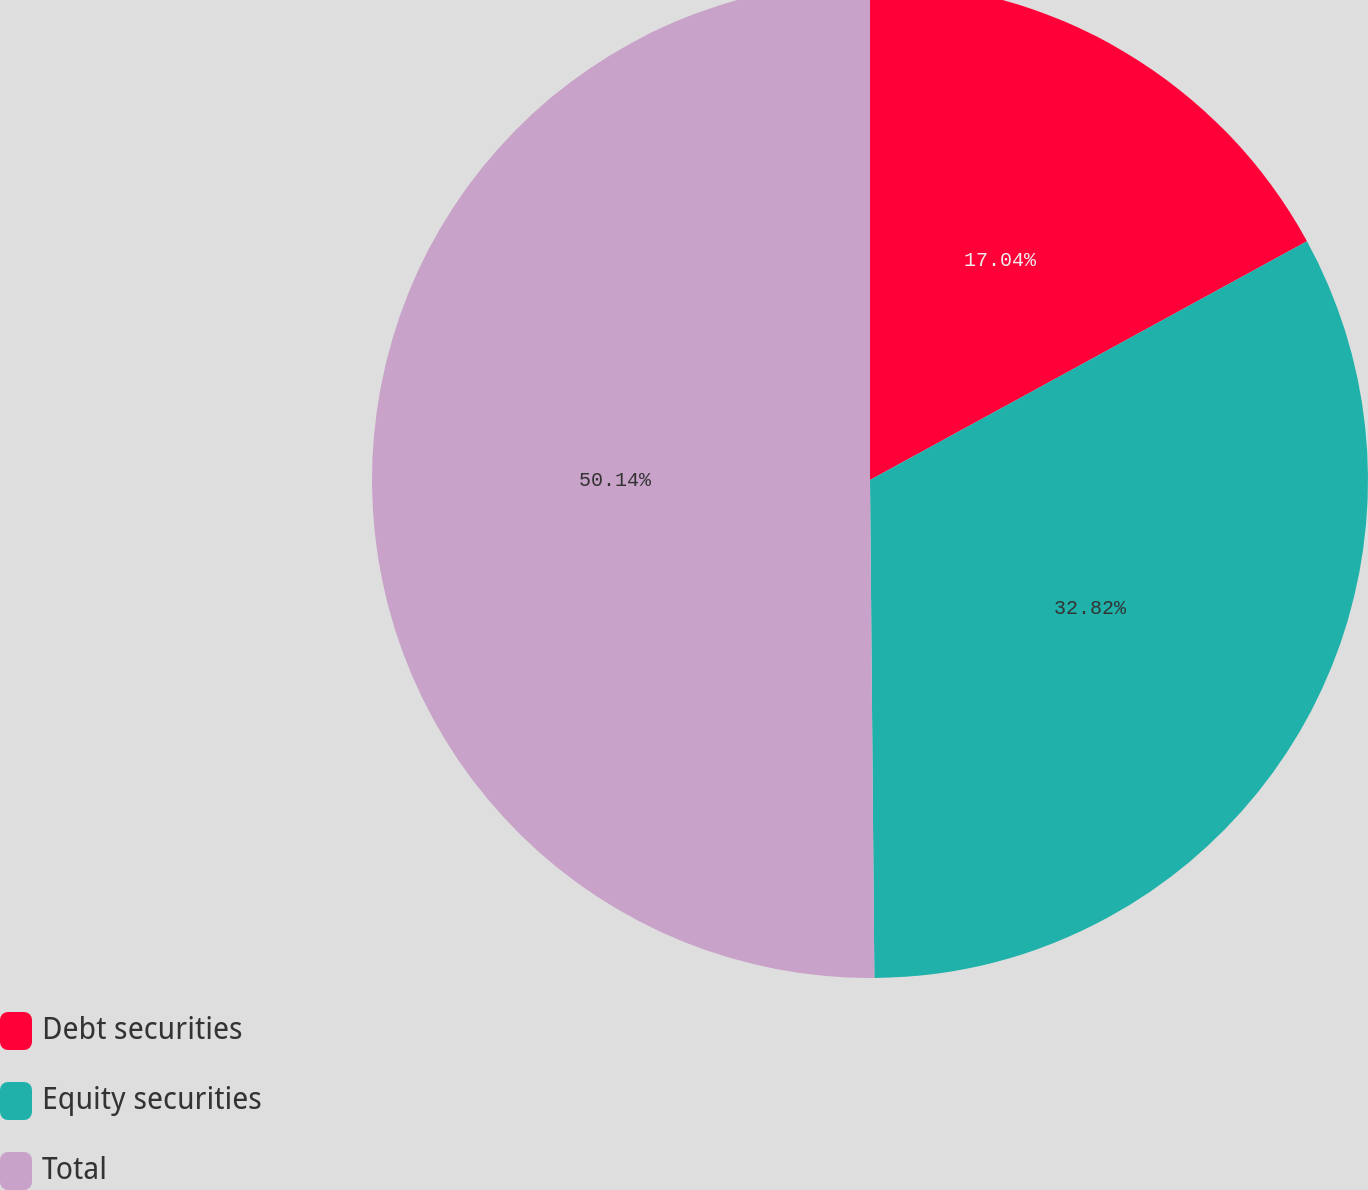Convert chart to OTSL. <chart><loc_0><loc_0><loc_500><loc_500><pie_chart><fcel>Debt securities<fcel>Equity securities<fcel>Total<nl><fcel>17.04%<fcel>32.82%<fcel>50.14%<nl></chart> 